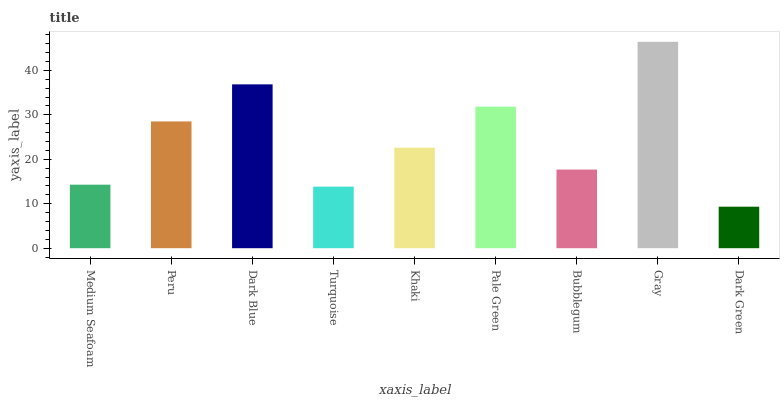Is Dark Green the minimum?
Answer yes or no. Yes. Is Gray the maximum?
Answer yes or no. Yes. Is Peru the minimum?
Answer yes or no. No. Is Peru the maximum?
Answer yes or no. No. Is Peru greater than Medium Seafoam?
Answer yes or no. Yes. Is Medium Seafoam less than Peru?
Answer yes or no. Yes. Is Medium Seafoam greater than Peru?
Answer yes or no. No. Is Peru less than Medium Seafoam?
Answer yes or no. No. Is Khaki the high median?
Answer yes or no. Yes. Is Khaki the low median?
Answer yes or no. Yes. Is Medium Seafoam the high median?
Answer yes or no. No. Is Dark Green the low median?
Answer yes or no. No. 